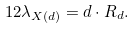Convert formula to latex. <formula><loc_0><loc_0><loc_500><loc_500>1 2 \lambda _ { X ( d ) } = d \cdot R _ { d } .</formula> 